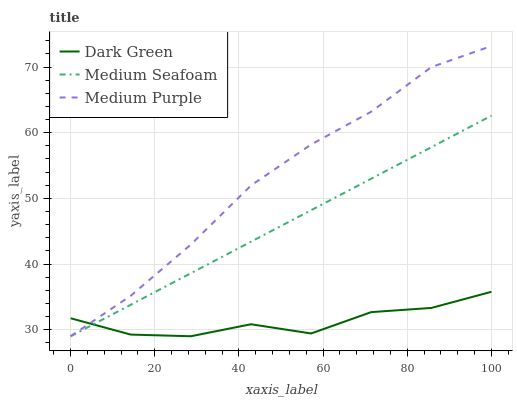Does Dark Green have the minimum area under the curve?
Answer yes or no. Yes. Does Medium Purple have the maximum area under the curve?
Answer yes or no. Yes. Does Medium Seafoam have the minimum area under the curve?
Answer yes or no. No. Does Medium Seafoam have the maximum area under the curve?
Answer yes or no. No. Is Medium Seafoam the smoothest?
Answer yes or no. Yes. Is Dark Green the roughest?
Answer yes or no. Yes. Is Dark Green the smoothest?
Answer yes or no. No. Is Medium Seafoam the roughest?
Answer yes or no. No. Does Medium Purple have the lowest value?
Answer yes or no. Yes. Does Medium Purple have the highest value?
Answer yes or no. Yes. Does Medium Seafoam have the highest value?
Answer yes or no. No. Does Medium Seafoam intersect Medium Purple?
Answer yes or no. Yes. Is Medium Seafoam less than Medium Purple?
Answer yes or no. No. Is Medium Seafoam greater than Medium Purple?
Answer yes or no. No. 